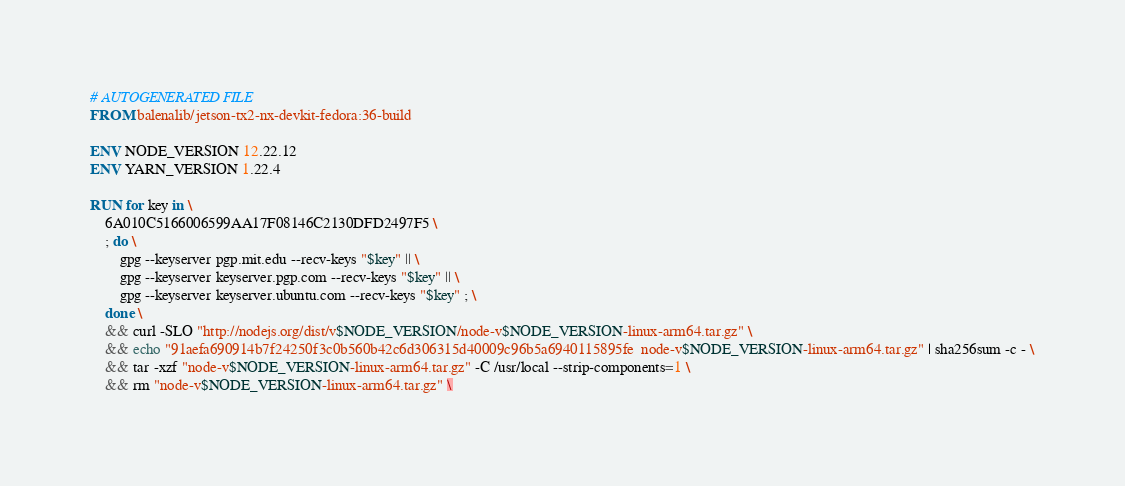<code> <loc_0><loc_0><loc_500><loc_500><_Dockerfile_># AUTOGENERATED FILE
FROM balenalib/jetson-tx2-nx-devkit-fedora:36-build

ENV NODE_VERSION 12.22.12
ENV YARN_VERSION 1.22.4

RUN for key in \
	6A010C5166006599AA17F08146C2130DFD2497F5 \
	; do \
		gpg --keyserver pgp.mit.edu --recv-keys "$key" || \
		gpg --keyserver keyserver.pgp.com --recv-keys "$key" || \
		gpg --keyserver keyserver.ubuntu.com --recv-keys "$key" ; \
	done \
	&& curl -SLO "http://nodejs.org/dist/v$NODE_VERSION/node-v$NODE_VERSION-linux-arm64.tar.gz" \
	&& echo "91aefa690914b7f24250f3c0b560b42c6d306315d40009c96b5a6940115895fe  node-v$NODE_VERSION-linux-arm64.tar.gz" | sha256sum -c - \
	&& tar -xzf "node-v$NODE_VERSION-linux-arm64.tar.gz" -C /usr/local --strip-components=1 \
	&& rm "node-v$NODE_VERSION-linux-arm64.tar.gz" \</code> 